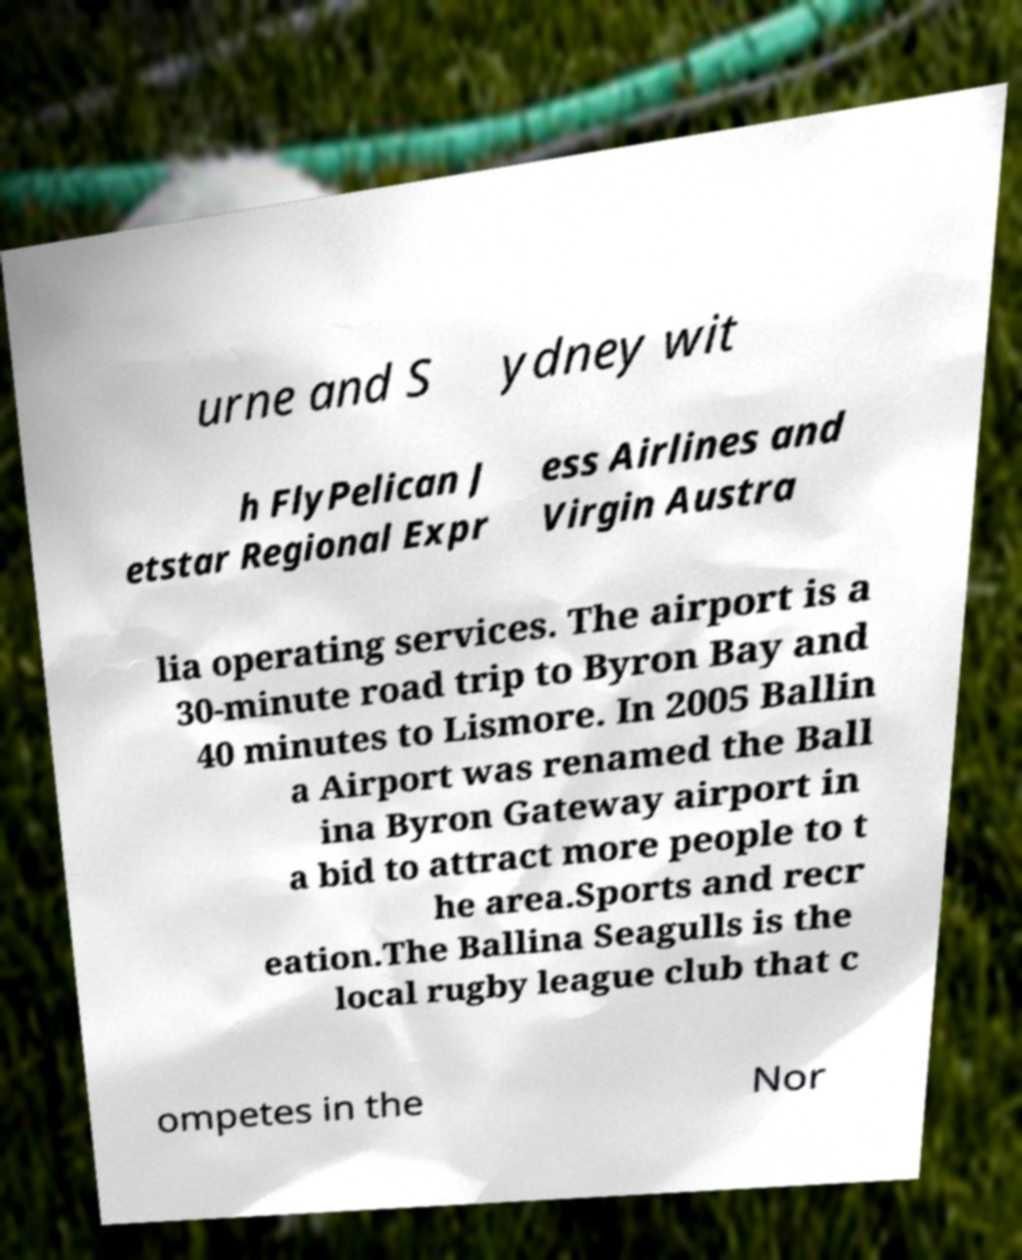Could you assist in decoding the text presented in this image and type it out clearly? urne and S ydney wit h FlyPelican J etstar Regional Expr ess Airlines and Virgin Austra lia operating services. The airport is a 30-minute road trip to Byron Bay and 40 minutes to Lismore. In 2005 Ballin a Airport was renamed the Ball ina Byron Gateway airport in a bid to attract more people to t he area.Sports and recr eation.The Ballina Seagulls is the local rugby league club that c ompetes in the Nor 